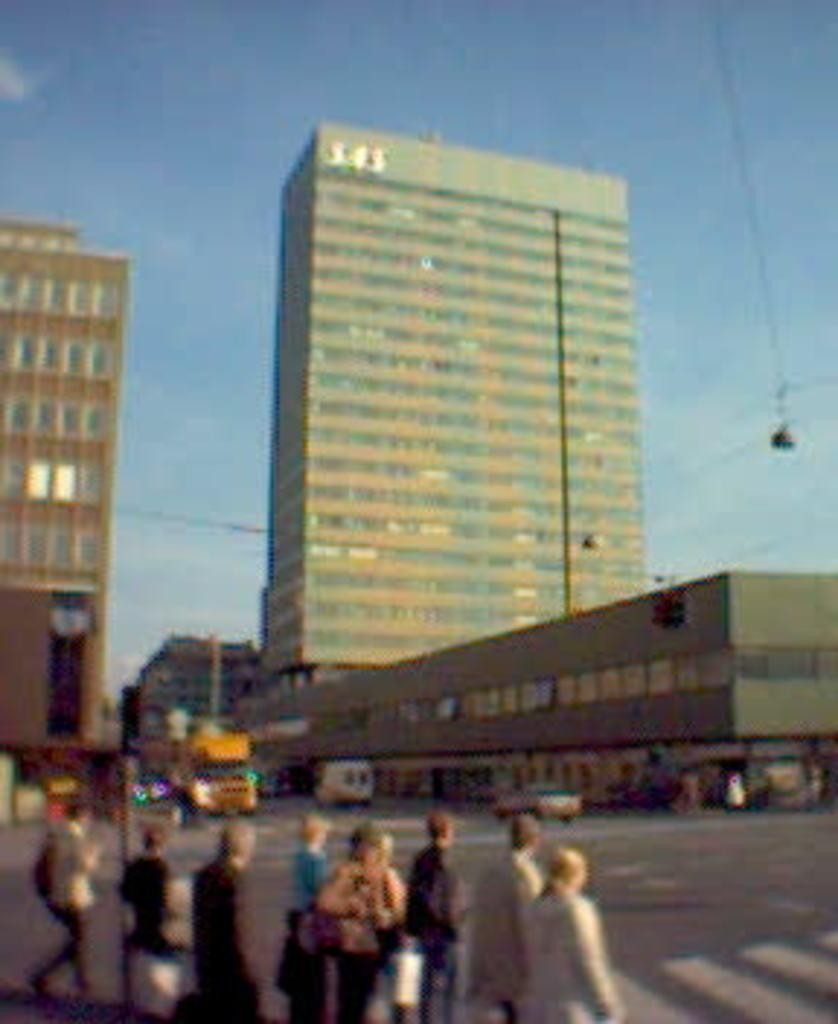What is happening with the group of people in the image? The group of men and women is crossing the road. What can be seen in the background of the image? There is a big building and a yellow color bus moving on the road in the background. What type of watch is the brick wearing in the image? There is no brick or watch present in the image. What flavor of pie is being served to the group of people in the image? There is no pie present in the image; the group is crossing the road. 